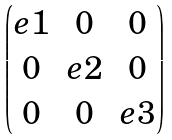Convert formula to latex. <formula><loc_0><loc_0><loc_500><loc_500>\begin{pmatrix} e 1 & 0 & 0 \\ 0 & e 2 & 0 \\ 0 & 0 & e 3 \\ \end{pmatrix}</formula> 